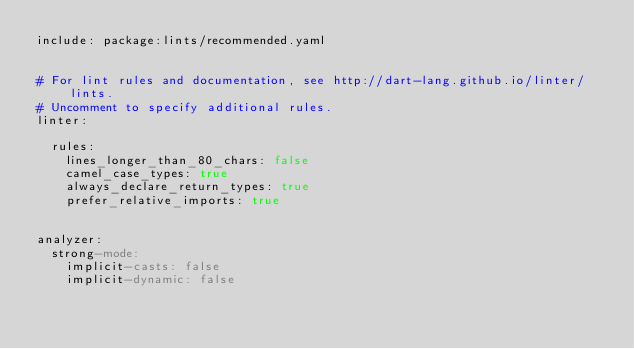<code> <loc_0><loc_0><loc_500><loc_500><_YAML_>include: package:lints/recommended.yaml


# For lint rules and documentation, see http://dart-lang.github.io/linter/lints.
# Uncomment to specify additional rules.
linter:
  
  rules:
    lines_longer_than_80_chars: false
    camel_case_types: true
    always_declare_return_types: true
    prefer_relative_imports: true
  

analyzer:
  strong-mode:
    implicit-casts: false
    implicit-dynamic: false
</code> 